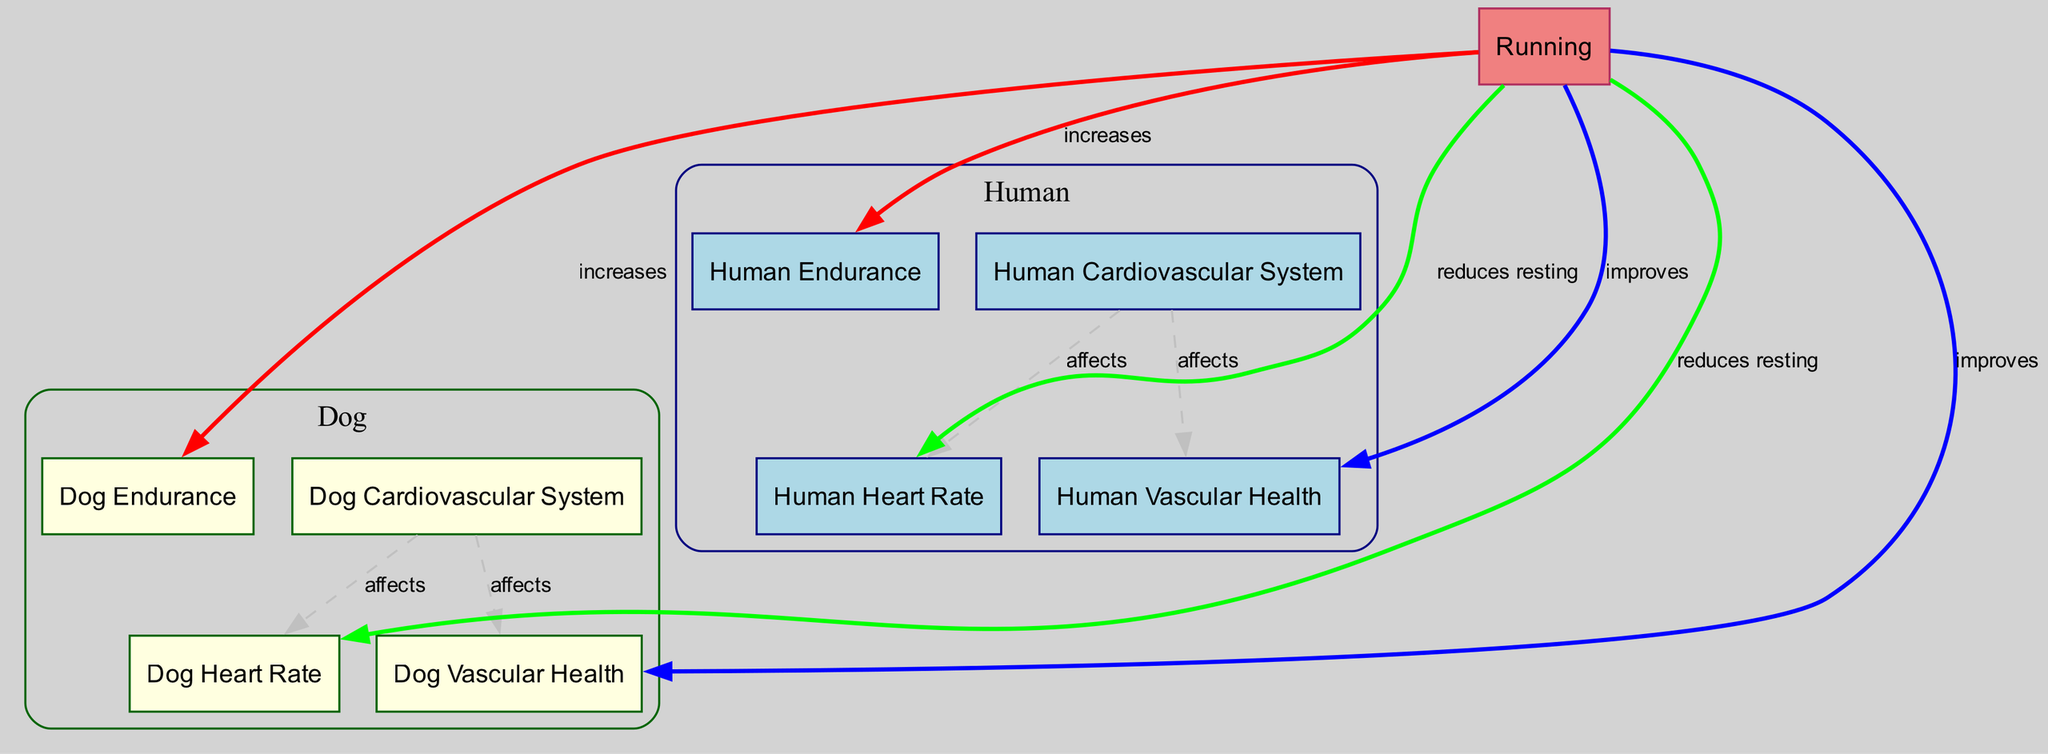What relationship exists between human cardiovascular system and human heart rate? The diagram shows a dashed arrow labeled "affects" connecting the "Human Cardiovascular System" node to the "Human Heart Rate" node. This indicates that the human cardiovascular system has an effect on the heart rate.
Answer: affects How many nodes are in the diagram? By counting the nodes listed in the data, there are 9 nodes in total: Human Cardiovascular System, Dog Cardiovascular System, Human Heart Rate, Dog Heart Rate, Human Vascular Health, Dog Vascular Health, Human Endurance, Dog Endurance, and Running.
Answer: 9 Which node indicates the impact of running on dog vascular health? The "Running" node is connected to the "Dog Vascular Health" node with a bold blue arrow labeled "improves", indicating that running has a positive impact on dog vascular health.
Answer: improves What effect does running have on human endurance? The diagram features a bold green arrow labeled "increases" that connects the "Running" node to the "Human Endurance" node, indicating that running increases human endurance.
Answer: increases Which cardiovascular system affects resting heart rate for dogs? The "Dog Cardiovascular System" node has a dashed arrow labeled "affects" leading to the "Dog Heart Rate" node, showing that it affects the resting heart rate of dogs.
Answer: Dog Cardiovascular System What is the connection between running and heart rate for both humans and dogs? The "Running" node connects to both the "Human Heart Rate" and "Dog Heart Rate" nodes with bold green arrows that indicate running reduces the resting heart rate for both humans and dogs.
Answer: reduces resting How does running influence vascular health in humans? The "Running" node is connected to the "Human Vascular Health" node with a bold blue arrow labeled "improves", indicating that running improves vascular health in humans.
Answer: improves Which two health aspects are improved by running for dogs? The diagram illustrates that running improves both "Dog Endurance" and "Dog Vascular Health", as indicated by bold arrows from the "Running" node to both nodes.
Answer: Dog Endurance and Dog Vascular Health 